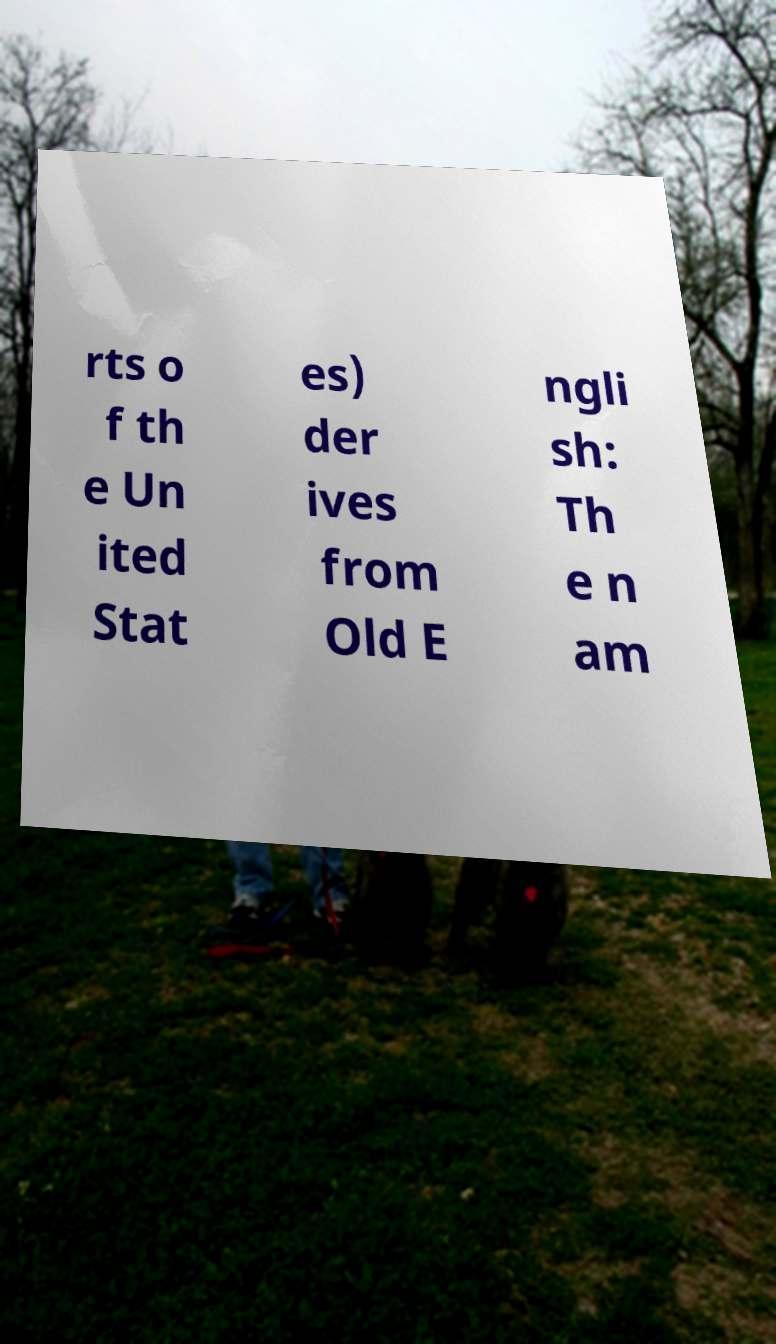What messages or text are displayed in this image? I need them in a readable, typed format. rts o f th e Un ited Stat es) der ives from Old E ngli sh: Th e n am 